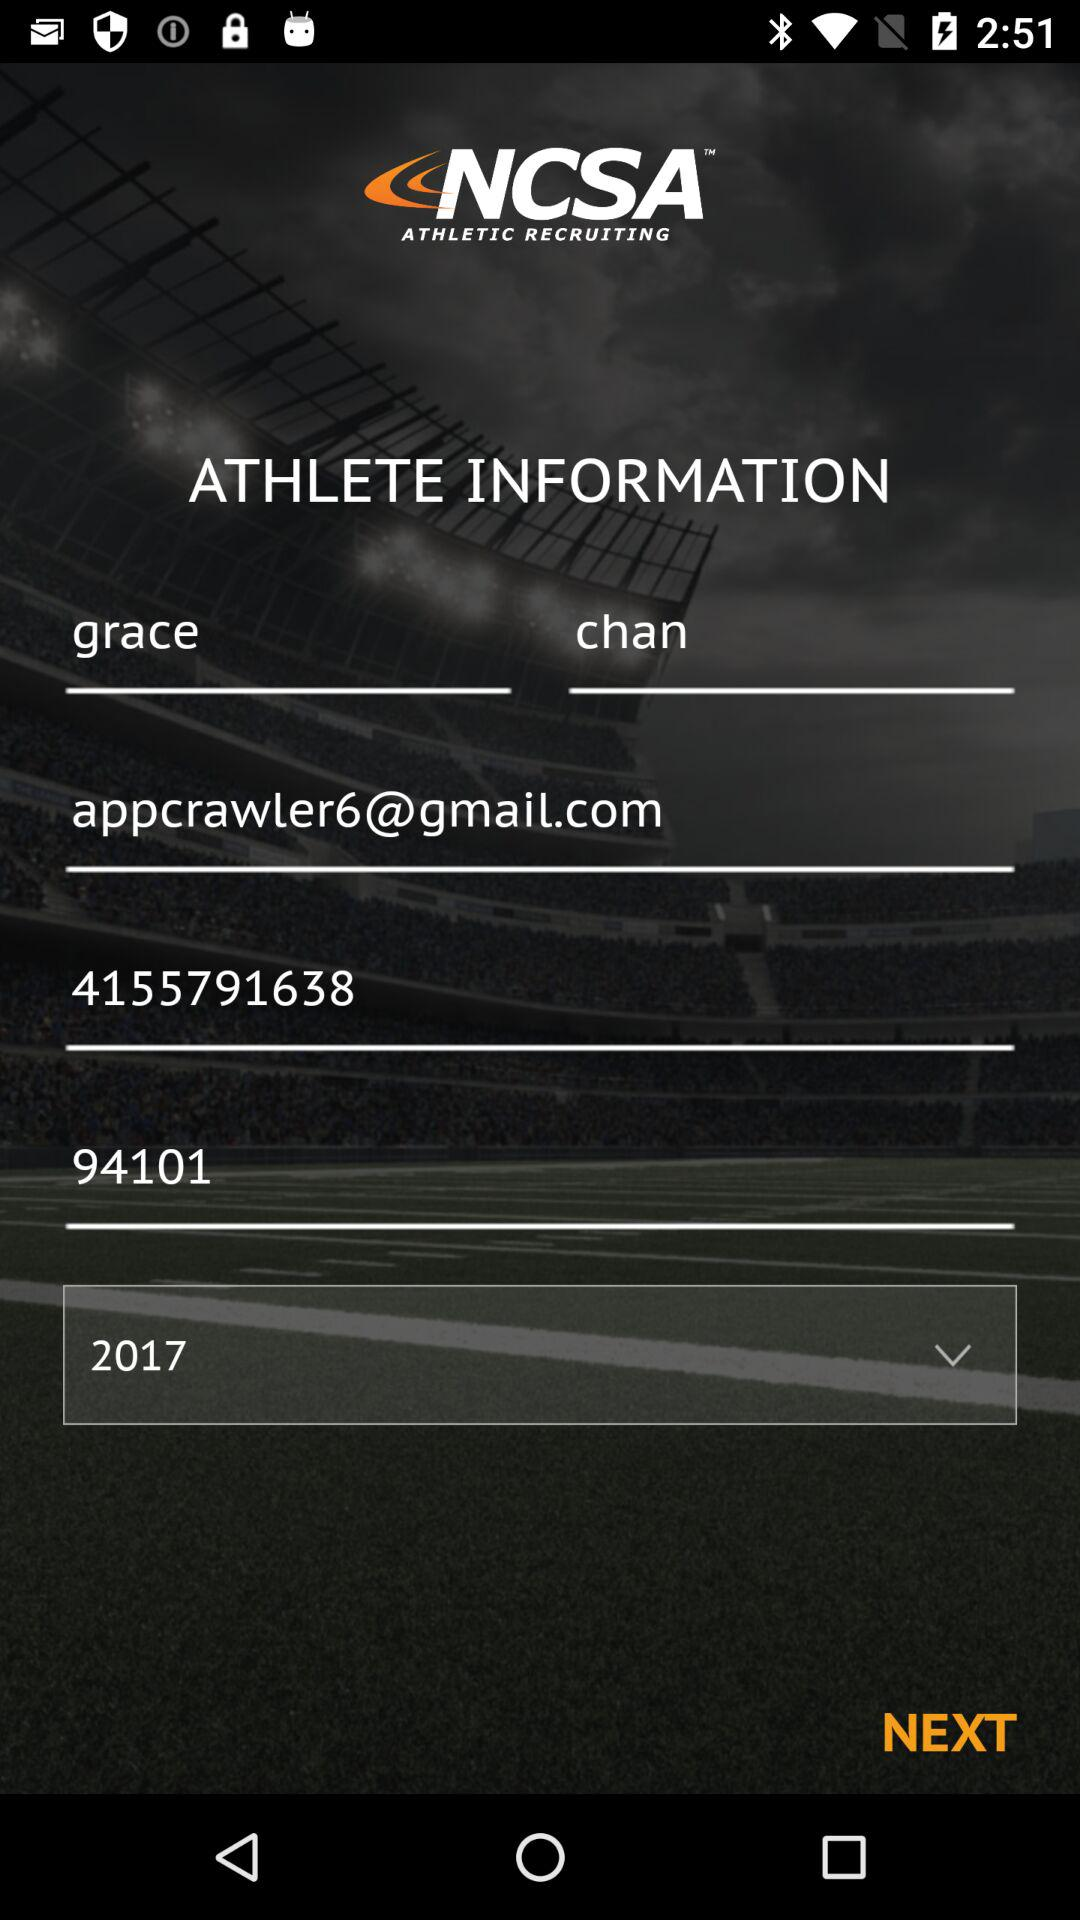When was Grace Chan born?
When the provided information is insufficient, respond with <no answer>. <no answer> 